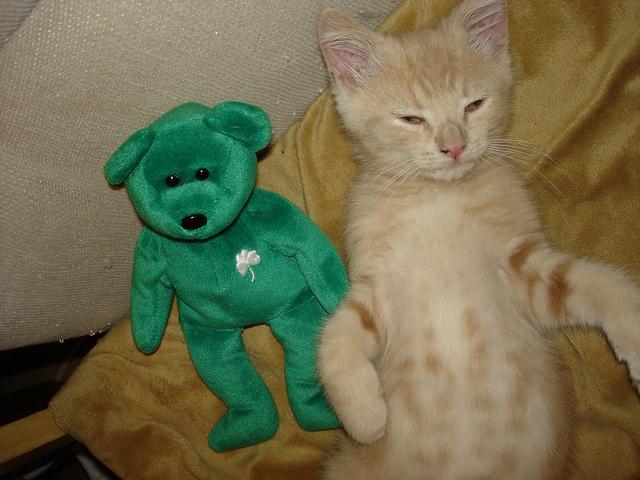What is embroidered on the teddy bear?
Give a very brief answer. Clover. Does the cat look happy?
Quick response, please. Yes. What animal has that paw?
Concise answer only. Cat. How many cats are in the picture?
Concise answer only. 1. What color is the doll?
Short answer required. Green. Does the cat appear to be playing with the toys?
Quick response, please. No. Is this a beanie baby bear?
Answer briefly. Yes. What color is the kitten?
Write a very short answer. Tan. Is the kitten being fed?
Quick response, please. No. Is the cat cuddling the stuffed animal?
Be succinct. No. Where is the animal sleeping?
Short answer required. Bed. What cartoon company do the characters belong to?
Answer briefly. None. Is the cat comfortable wearing a hat?
Short answer required. No. What colors are primarily seen in the image?
Short answer required. Green and brown. What is the cat doing near the bear?
Concise answer only. Sleeping. What colors are the cat?
Write a very short answer. Orange and brown. What color is the bear on the bed?
Write a very short answer. Green. What kind of cat is this?
Keep it brief. Kitten. Are they against a wall?
Be succinct. Yes. What color is the cat?
Give a very brief answer. Tan. Is the picture colorful?
Be succinct. Yes. What is the softest item in the image?
Quick response, please. Kitten. What is the cat doing?
Quick response, please. Laying. How many animals are in the image?
Give a very brief answer. 1. What is the cat resting in?
Give a very brief answer. Blanket. What cat is this?
Short answer required. Kitten. Is the cat wearing an ID tag?
Quick response, please. No. Where is this kitten looking?
Keep it brief. Up. Is the cat wearing a hat?
Concise answer only. No. What color is the bear?
Answer briefly. Green. What color is the cat on the chair?
Concise answer only. Tan. How many ears can you see?
Give a very brief answer. 4. What is beside the cat?
Short answer required. Teddy bear. Is it normal for cats to get into suitcases?
Be succinct. Yes. Is this cat annoyed with the camera person?
Quick response, please. Yes. What is on the teddy bear's body?
Concise answer only. Clover. What is the animal?
Answer briefly. Cat. Does the cat want to travel?
Answer briefly. No. Is the cat angry?
Answer briefly. No. Is this cat hungry?
Be succinct. No. What color are the cat's eyes?
Answer briefly. Green. What breed of cat is this?
Be succinct. Mixed. How many kittens are there?
Write a very short answer. 1. Does the cat match the sofa?
Concise answer only. Yes. Can the cat see its leg in the reflection?
Concise answer only. No. What color is the object on the left wearing?
Quick response, please. Green. What is on the cat's head?
Answer briefly. Nothing. Is the cat annoyed?
Answer briefly. Yes. Is the stuff animal patterned?
Give a very brief answer. No. Which of the animals shown is having a very bad day?
Short answer required. Cat. 